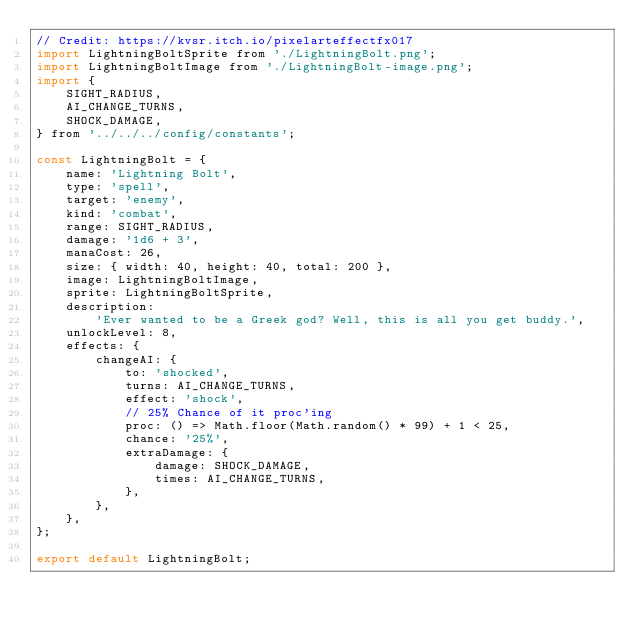<code> <loc_0><loc_0><loc_500><loc_500><_JavaScript_>// Credit: https://kvsr.itch.io/pixelarteffectfx017
import LightningBoltSprite from './LightningBolt.png';
import LightningBoltImage from './LightningBolt-image.png';
import {
    SIGHT_RADIUS,
    AI_CHANGE_TURNS,
    SHOCK_DAMAGE,
} from '../../../config/constants';

const LightningBolt = {
    name: 'Lightning Bolt',
    type: 'spell',
    target: 'enemy',
    kind: 'combat',
    range: SIGHT_RADIUS,
    damage: '1d6 + 3',
    manaCost: 26,
    size: { width: 40, height: 40, total: 200 },
    image: LightningBoltImage,
    sprite: LightningBoltSprite,
    description:
        'Ever wanted to be a Greek god? Well, this is all you get buddy.',
    unlockLevel: 8,
    effects: {
        changeAI: {
            to: 'shocked',
            turns: AI_CHANGE_TURNS,
            effect: 'shock',
            // 25% Chance of it proc'ing
            proc: () => Math.floor(Math.random() * 99) + 1 < 25,
            chance: '25%',
            extraDamage: {
                damage: SHOCK_DAMAGE,
                times: AI_CHANGE_TURNS,
            },
        },
    },
};

export default LightningBolt;
</code> 